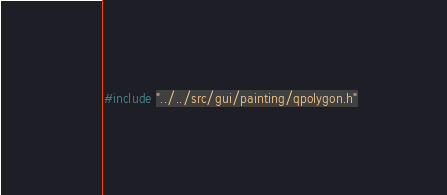<code> <loc_0><loc_0><loc_500><loc_500><_C_>#include "../../src/gui/painting/qpolygon.h"
</code> 